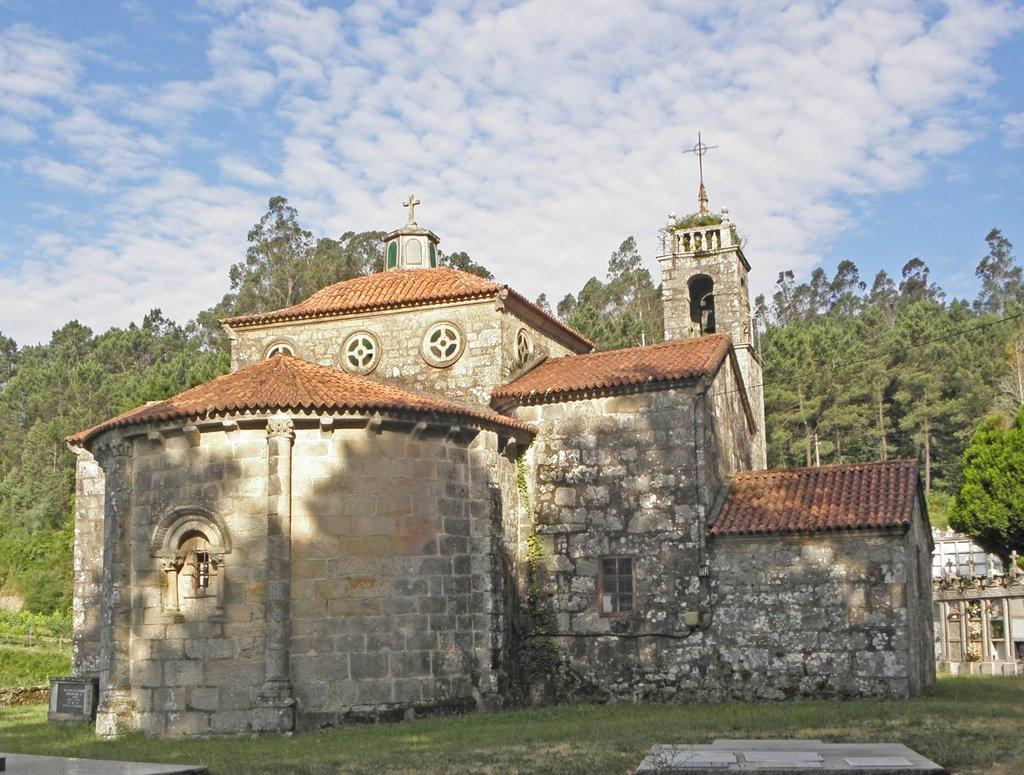What type of structure is visible in the image? There is a building in the image. What type of vegetation can be seen in the image? There are trees and grass present in the image. What is visible in the sky in the image? There are clouds in the image, and the sky is visible. What type of discussion is taking place between the clouds in the image? There is no discussion between the clouds in the image, as clouds do not have the ability to engage in discussions. 